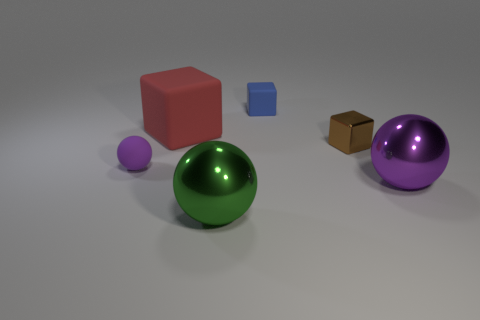There is a metal sphere that is the same color as the tiny matte sphere; what size is it?
Keep it short and to the point. Large. There is a purple object in front of the tiny purple rubber object; does it have the same shape as the tiny purple object?
Your response must be concise. Yes. The shiny thing that is the same shape as the red matte thing is what color?
Ensure brevity in your answer.  Brown. Do the small blue object and the brown metallic thing have the same shape?
Your response must be concise. Yes. Are there any small shiny cubes in front of the large red rubber cube?
Provide a succinct answer. Yes. How many objects are either small blue rubber objects or large cyan spheres?
Offer a terse response. 1. What number of spheres are behind the green object and right of the purple matte thing?
Give a very brief answer. 1. There is a shiny ball that is on the right side of the blue matte block; is its size the same as the metallic thing behind the small rubber ball?
Offer a very short reply. No. There is a purple object to the left of the big purple metal thing; what size is it?
Provide a succinct answer. Small. What number of things are either tiny things that are behind the shiny block or purple things that are to the right of the large red matte thing?
Make the answer very short. 2. 